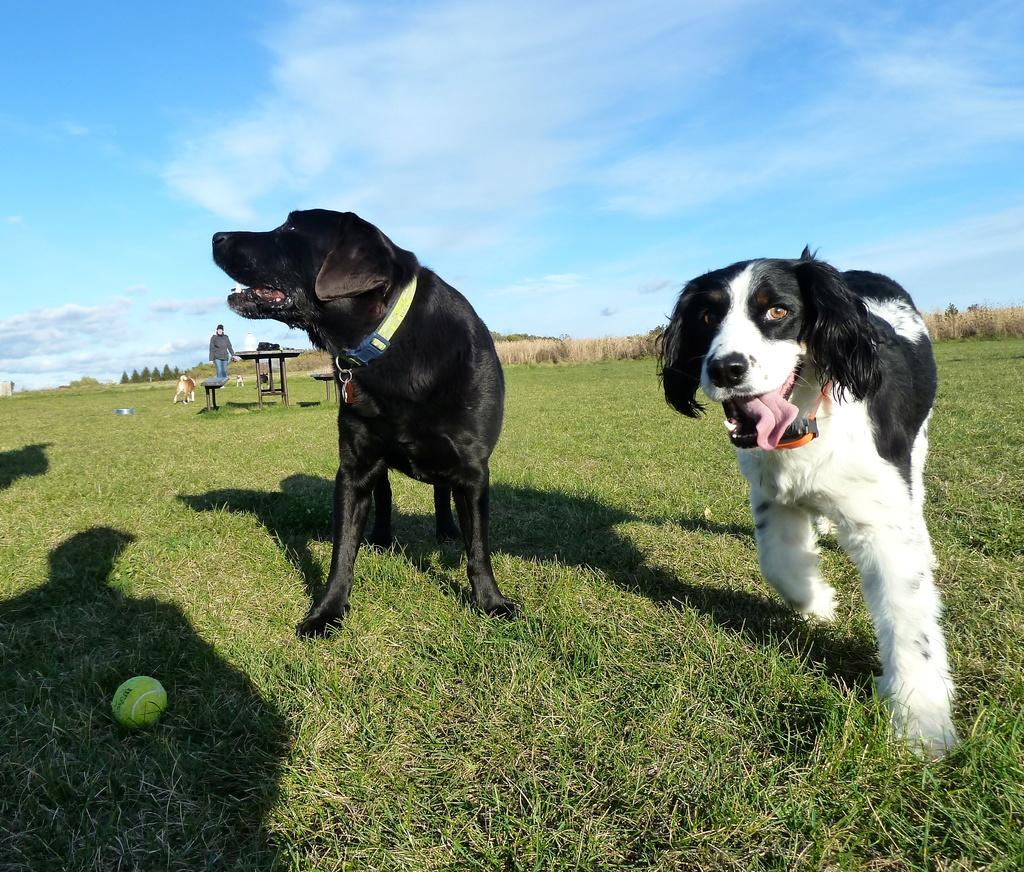How many dogs are present in the garden in the image? There are three dogs in the garden in the image. What object can be seen in the image besides the dogs? There is a ball in the image. Can you describe the person in the image? There is a person standing in the image. What type of furniture is present in the image? There is a table and a bench in the image. How does the ticket look like in the image? There is no ticket present in the image. 